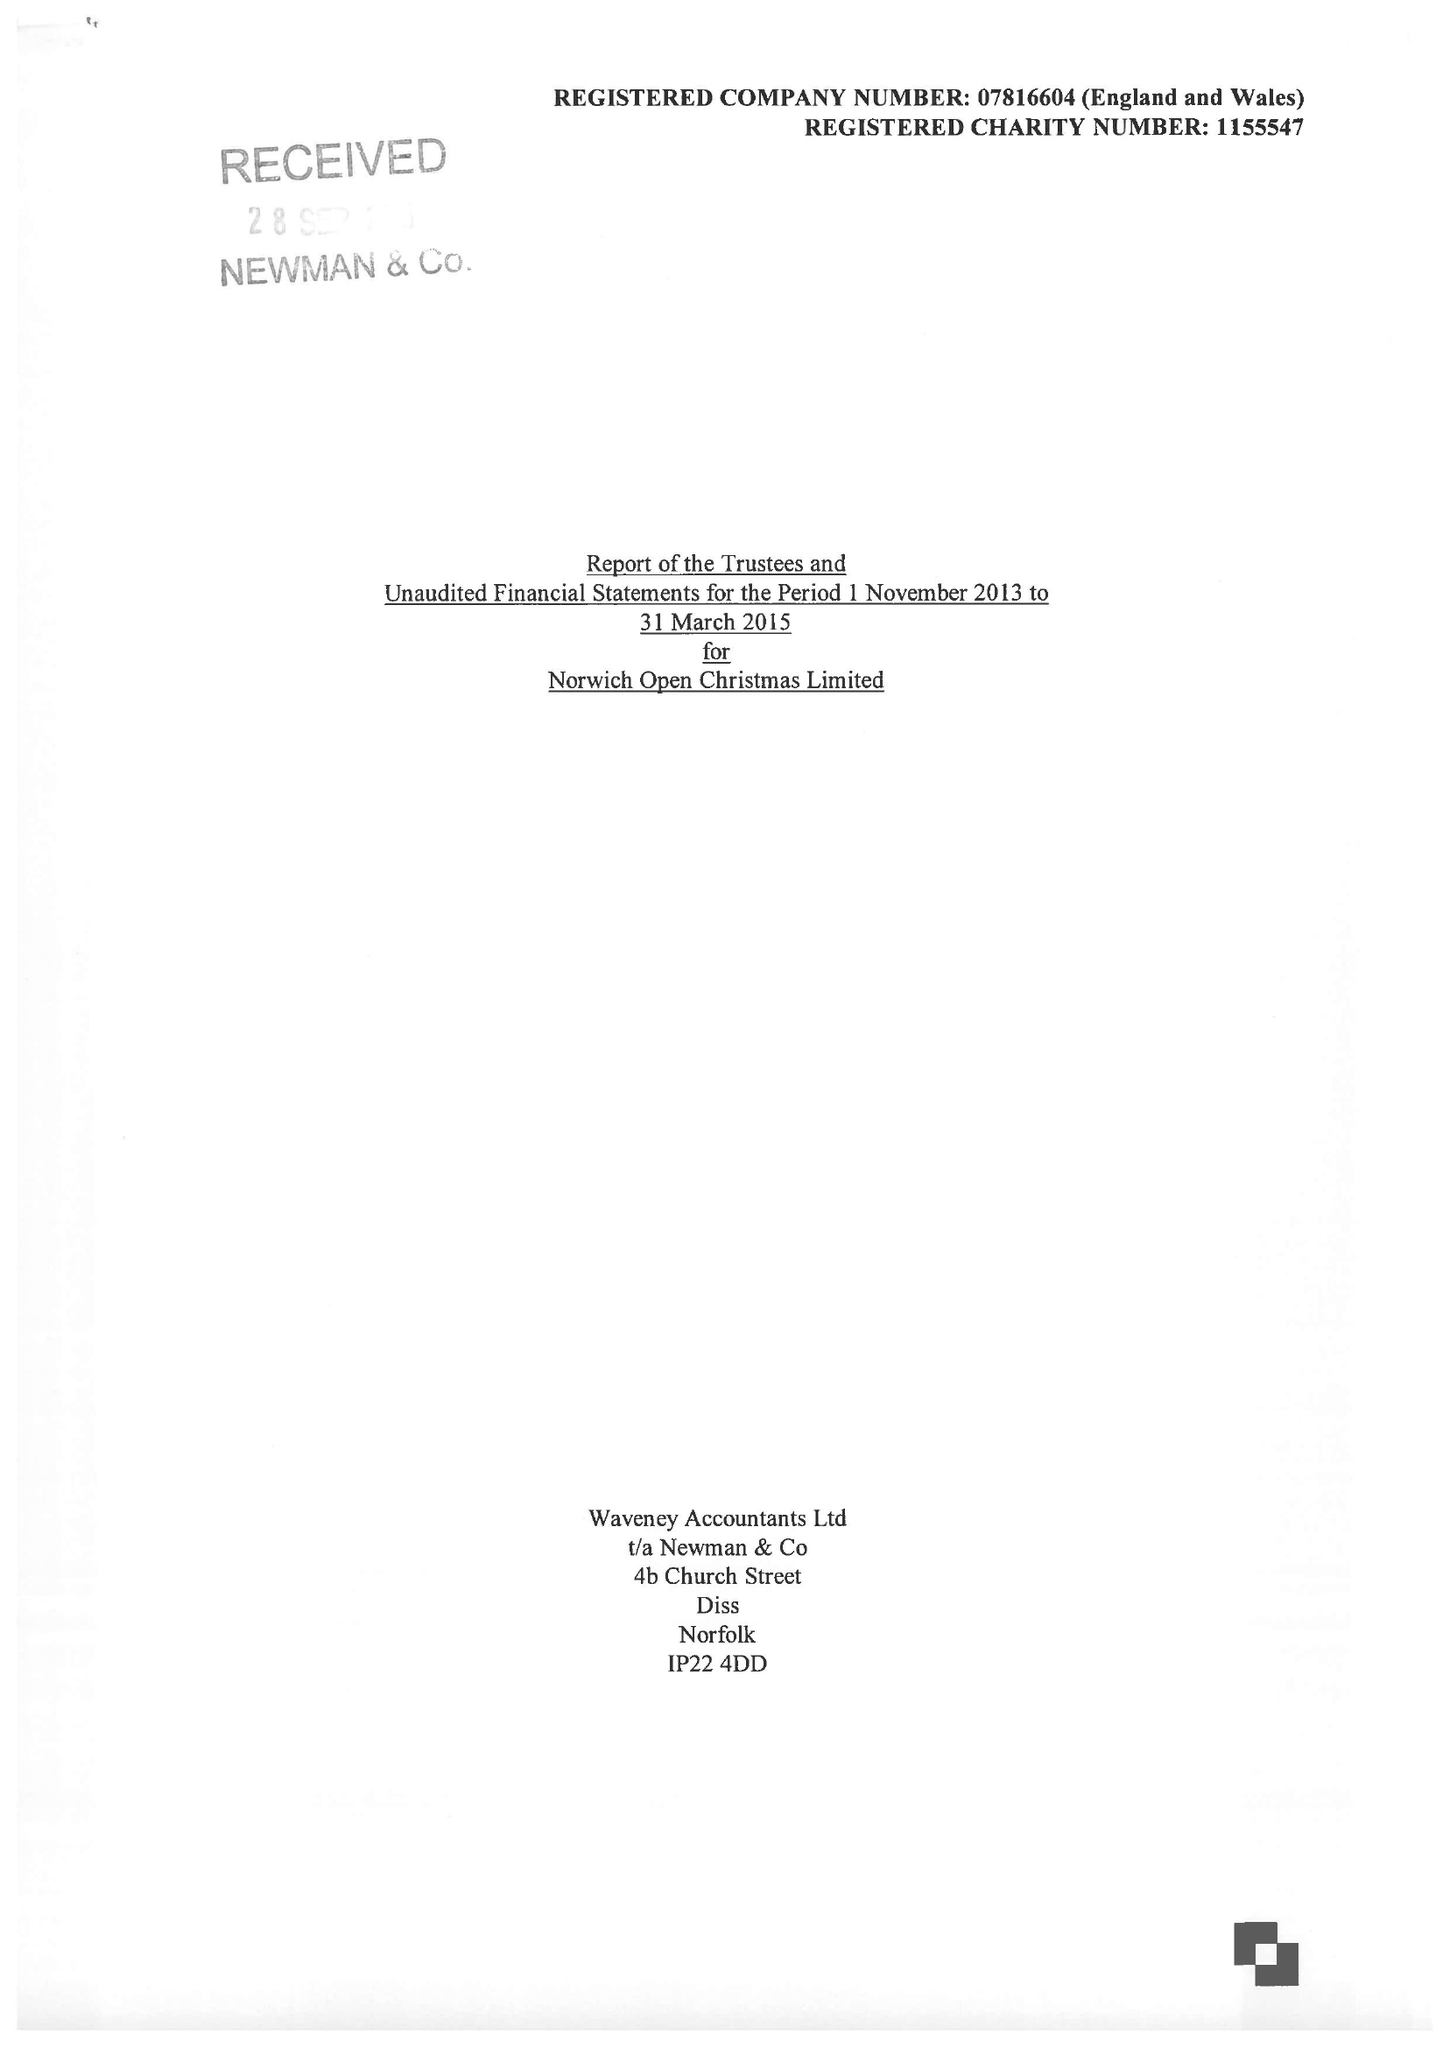What is the value for the income_annually_in_british_pounds?
Answer the question using a single word or phrase. 28849.00 